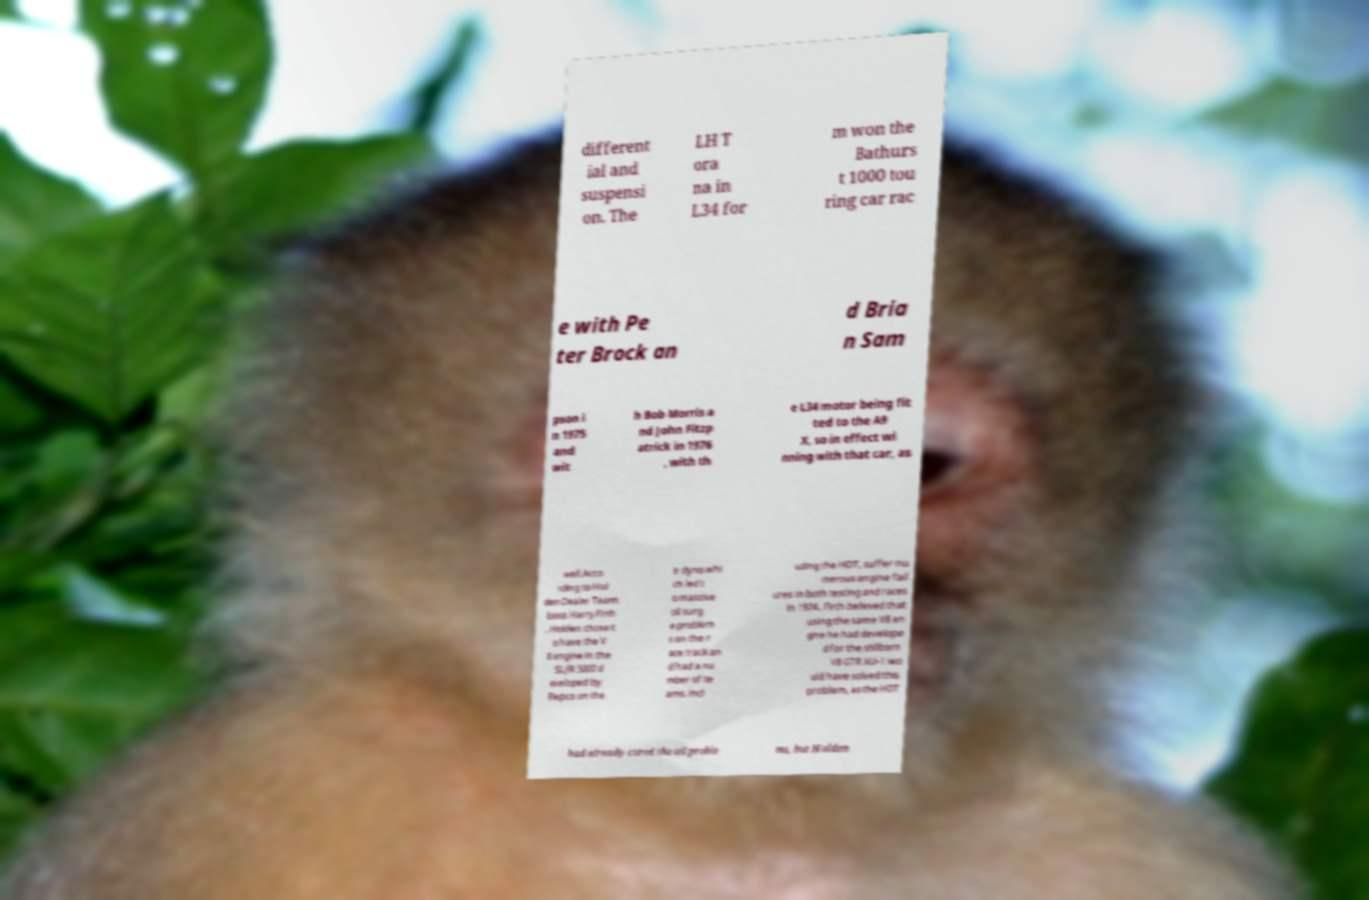Could you assist in decoding the text presented in this image and type it out clearly? different ial and suspensi on. The LH T ora na in L34 for m won the Bathurs t 1000 tou ring car rac e with Pe ter Brock an d Bria n Sam pson i n 1975 and wit h Bob Morris a nd John Fitzp atrick in 1976 , with th e L34 motor being fit ted to the A9 X, so in effect wi nning with that car, as well.Acco rding to Hol den Dealer Team boss Harry Firth , Holden chose t o have the V 8 engine in the SL/R 5000 d eveloped by Repco on the ir dyno whi ch led t o massive oil surg e problem s on the r ace track an d had a nu mber of te ams, incl uding the HDT, suffer nu merous engine fail ures in both testing and races in 1974. Firth believed that using the same V8 en gine he had develope d for the stillborn V8 GTR XU-1 wo uld have solved this problem, as the HDT had already cured the oil proble ms, but Holden 